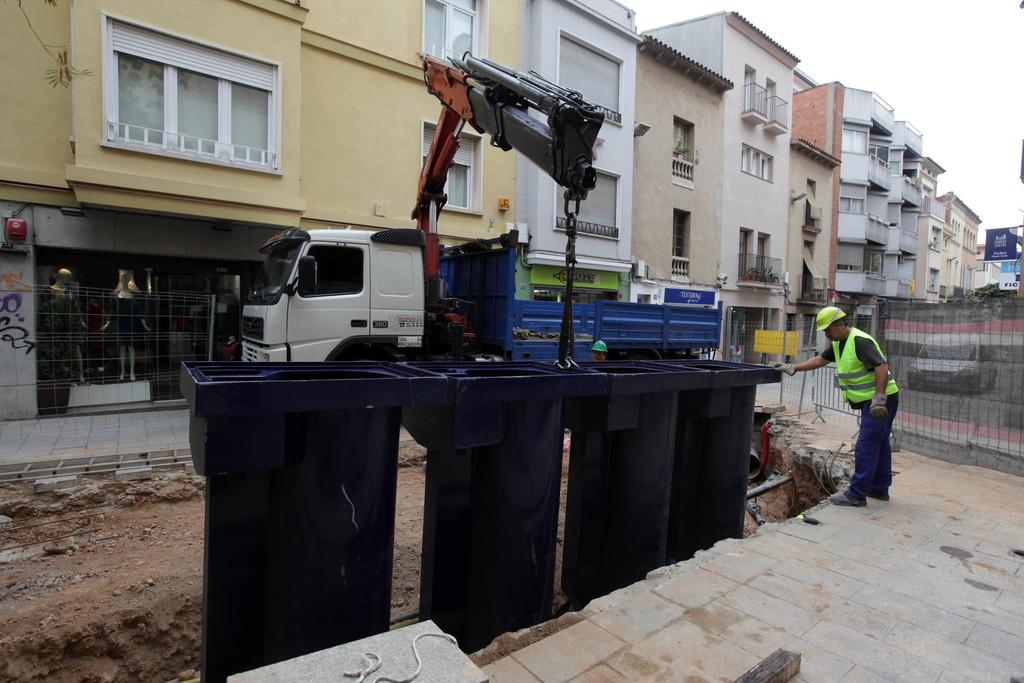What is the main subject of the image? There is a man standing in the image. What objects can be seen in the image related to waste management? There are bins in the image. What type of vehicles can be seen in the image? Vehicles are present on the road in the image. What is the purpose of the fence in the image? The fence is likely used to separate or enclose an area. What construction equipment is visible in the image? A crane is visible on a truck in the image. What type of signs or notices can be seen in the image? There are boards in the image. What type of structures are present in the image? Buildings are present in the image. What is visible in the background of the image? The sky is visible in the background of the image. What card game is the man playing in the image? There is no card game visible in the image; the man is simply standing. How many steps does the crane take to reach the top of the building in the image? The image does not show the crane in action or provide information about its movement, so it is impossible to determine the number of steps it takes to reach the top of the building. 